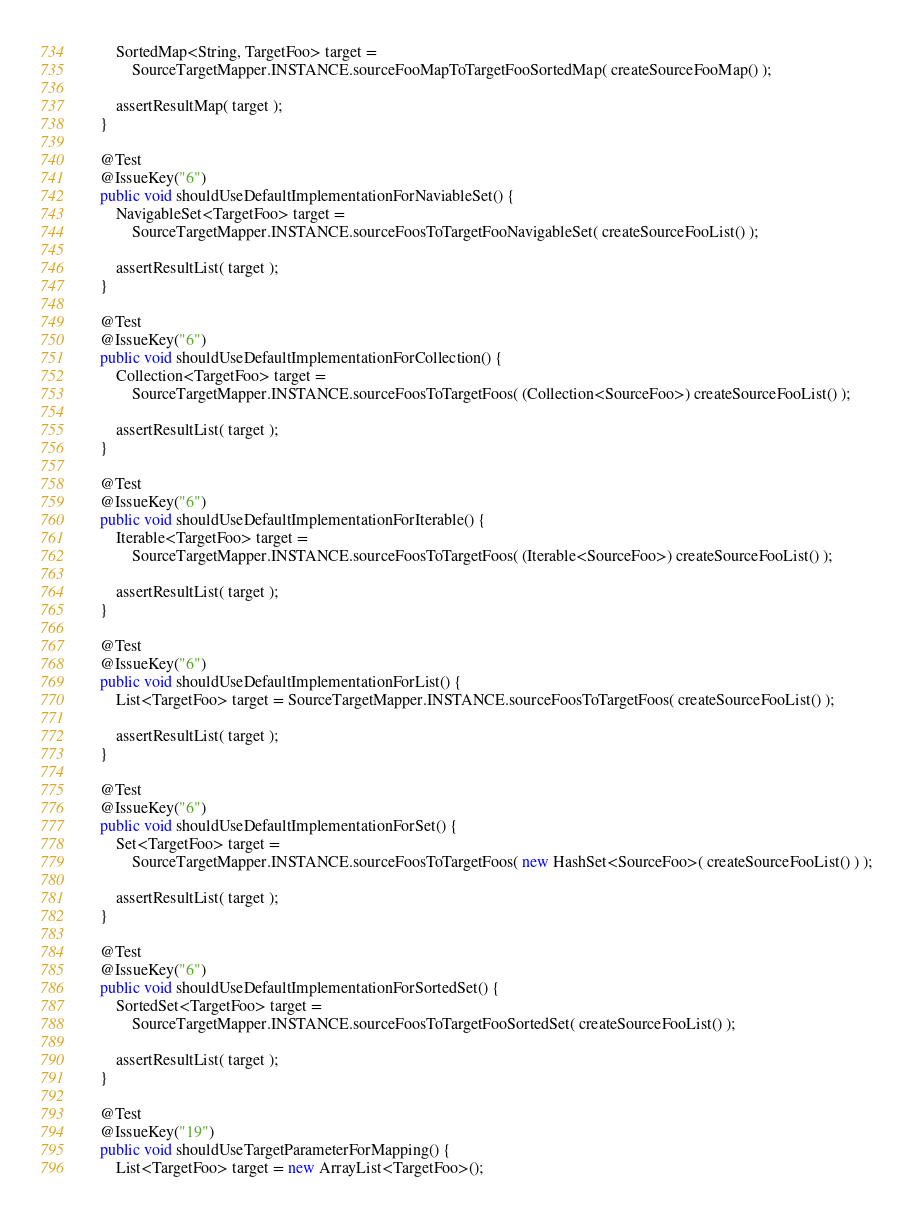<code> <loc_0><loc_0><loc_500><loc_500><_Java_>        SortedMap<String, TargetFoo> target =
            SourceTargetMapper.INSTANCE.sourceFooMapToTargetFooSortedMap( createSourceFooMap() );

        assertResultMap( target );
    }

    @Test
    @IssueKey("6")
    public void shouldUseDefaultImplementationForNaviableSet() {
        NavigableSet<TargetFoo> target =
            SourceTargetMapper.INSTANCE.sourceFoosToTargetFooNavigableSet( createSourceFooList() );

        assertResultList( target );
    }

    @Test
    @IssueKey("6")
    public void shouldUseDefaultImplementationForCollection() {
        Collection<TargetFoo> target =
            SourceTargetMapper.INSTANCE.sourceFoosToTargetFoos( (Collection<SourceFoo>) createSourceFooList() );

        assertResultList( target );
    }

    @Test
    @IssueKey("6")
    public void shouldUseDefaultImplementationForIterable() {
        Iterable<TargetFoo> target =
            SourceTargetMapper.INSTANCE.sourceFoosToTargetFoos( (Iterable<SourceFoo>) createSourceFooList() );

        assertResultList( target );
    }

    @Test
    @IssueKey("6")
    public void shouldUseDefaultImplementationForList() {
        List<TargetFoo> target = SourceTargetMapper.INSTANCE.sourceFoosToTargetFoos( createSourceFooList() );

        assertResultList( target );
    }

    @Test
    @IssueKey("6")
    public void shouldUseDefaultImplementationForSet() {
        Set<TargetFoo> target =
            SourceTargetMapper.INSTANCE.sourceFoosToTargetFoos( new HashSet<SourceFoo>( createSourceFooList() ) );

        assertResultList( target );
    }

    @Test
    @IssueKey("6")
    public void shouldUseDefaultImplementationForSortedSet() {
        SortedSet<TargetFoo> target =
            SourceTargetMapper.INSTANCE.sourceFoosToTargetFooSortedSet( createSourceFooList() );

        assertResultList( target );
    }

    @Test
    @IssueKey("19")
    public void shouldUseTargetParameterForMapping() {
        List<TargetFoo> target = new ArrayList<TargetFoo>();</code> 